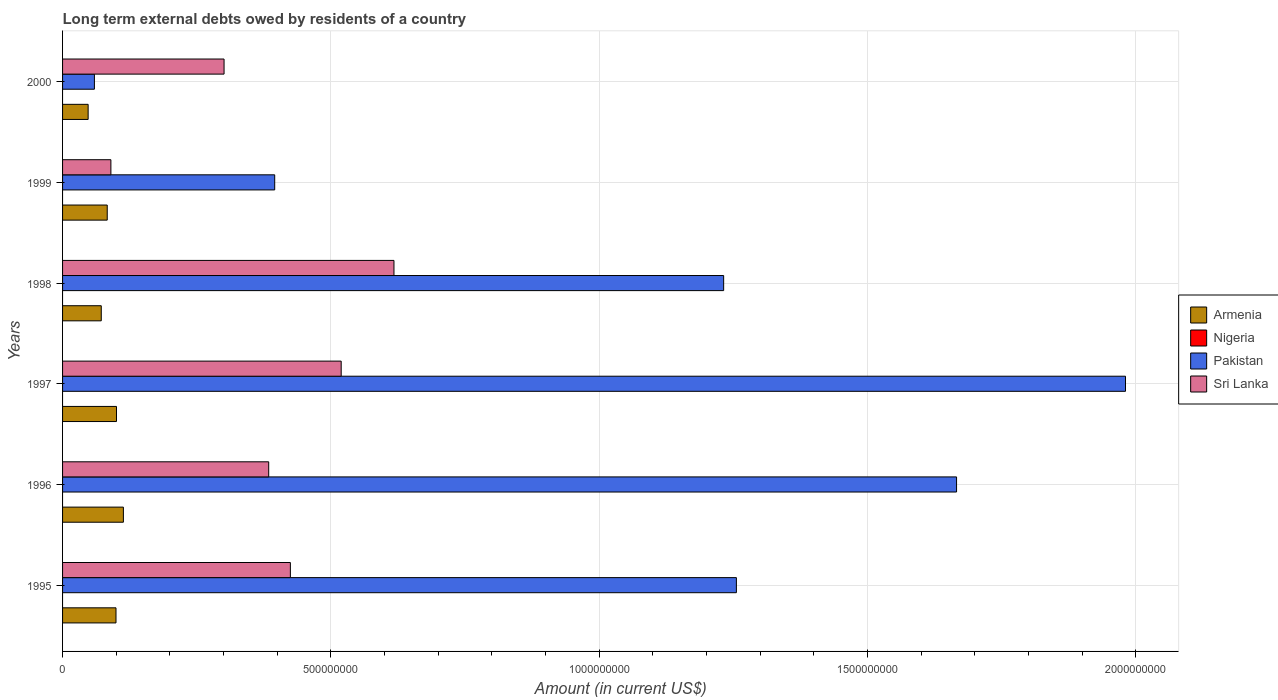How many different coloured bars are there?
Offer a very short reply. 3. How many bars are there on the 5th tick from the top?
Ensure brevity in your answer.  3. How many bars are there on the 6th tick from the bottom?
Provide a succinct answer. 3. In how many cases, is the number of bars for a given year not equal to the number of legend labels?
Offer a terse response. 6. Across all years, what is the maximum amount of long-term external debts owed by residents in Sri Lanka?
Offer a terse response. 6.17e+08. Across all years, what is the minimum amount of long-term external debts owed by residents in Sri Lanka?
Offer a very short reply. 9.00e+07. What is the total amount of long-term external debts owed by residents in Pakistan in the graph?
Provide a succinct answer. 6.59e+09. What is the difference between the amount of long-term external debts owed by residents in Armenia in 1997 and that in 1999?
Your answer should be very brief. 1.72e+07. What is the difference between the amount of long-term external debts owed by residents in Pakistan in 1995 and the amount of long-term external debts owed by residents in Sri Lanka in 1997?
Your answer should be compact. 7.36e+08. In the year 1995, what is the difference between the amount of long-term external debts owed by residents in Armenia and amount of long-term external debts owed by residents in Pakistan?
Your answer should be compact. -1.16e+09. What is the ratio of the amount of long-term external debts owed by residents in Armenia in 1995 to that in 1999?
Ensure brevity in your answer.  1.2. Is the difference between the amount of long-term external debts owed by residents in Armenia in 1997 and 1999 greater than the difference between the amount of long-term external debts owed by residents in Pakistan in 1997 and 1999?
Keep it short and to the point. No. What is the difference between the highest and the second highest amount of long-term external debts owed by residents in Sri Lanka?
Your response must be concise. 9.83e+07. What is the difference between the highest and the lowest amount of long-term external debts owed by residents in Sri Lanka?
Your answer should be very brief. 5.27e+08. In how many years, is the amount of long-term external debts owed by residents in Nigeria greater than the average amount of long-term external debts owed by residents in Nigeria taken over all years?
Keep it short and to the point. 0. Is it the case that in every year, the sum of the amount of long-term external debts owed by residents in Nigeria and amount of long-term external debts owed by residents in Armenia is greater than the sum of amount of long-term external debts owed by residents in Sri Lanka and amount of long-term external debts owed by residents in Pakistan?
Provide a short and direct response. No. Is it the case that in every year, the sum of the amount of long-term external debts owed by residents in Sri Lanka and amount of long-term external debts owed by residents in Pakistan is greater than the amount of long-term external debts owed by residents in Armenia?
Give a very brief answer. Yes. How many years are there in the graph?
Give a very brief answer. 6. Where does the legend appear in the graph?
Make the answer very short. Center right. What is the title of the graph?
Your answer should be compact. Long term external debts owed by residents of a country. Does "Aruba" appear as one of the legend labels in the graph?
Give a very brief answer. No. What is the label or title of the X-axis?
Offer a very short reply. Amount (in current US$). What is the Amount (in current US$) of Armenia in 1995?
Your answer should be very brief. 9.95e+07. What is the Amount (in current US$) of Pakistan in 1995?
Your answer should be compact. 1.26e+09. What is the Amount (in current US$) of Sri Lanka in 1995?
Your answer should be very brief. 4.24e+08. What is the Amount (in current US$) in Armenia in 1996?
Your response must be concise. 1.13e+08. What is the Amount (in current US$) in Nigeria in 1996?
Provide a short and direct response. 0. What is the Amount (in current US$) of Pakistan in 1996?
Your response must be concise. 1.67e+09. What is the Amount (in current US$) of Sri Lanka in 1996?
Provide a short and direct response. 3.84e+08. What is the Amount (in current US$) in Armenia in 1997?
Offer a very short reply. 1.00e+08. What is the Amount (in current US$) of Pakistan in 1997?
Your answer should be very brief. 1.98e+09. What is the Amount (in current US$) in Sri Lanka in 1997?
Your response must be concise. 5.19e+08. What is the Amount (in current US$) in Armenia in 1998?
Ensure brevity in your answer.  7.21e+07. What is the Amount (in current US$) in Pakistan in 1998?
Ensure brevity in your answer.  1.23e+09. What is the Amount (in current US$) in Sri Lanka in 1998?
Your response must be concise. 6.17e+08. What is the Amount (in current US$) in Armenia in 1999?
Give a very brief answer. 8.32e+07. What is the Amount (in current US$) of Nigeria in 1999?
Your answer should be compact. 0. What is the Amount (in current US$) in Pakistan in 1999?
Your response must be concise. 3.95e+08. What is the Amount (in current US$) of Sri Lanka in 1999?
Give a very brief answer. 9.00e+07. What is the Amount (in current US$) in Armenia in 2000?
Make the answer very short. 4.77e+07. What is the Amount (in current US$) of Nigeria in 2000?
Make the answer very short. 0. What is the Amount (in current US$) of Pakistan in 2000?
Your answer should be very brief. 5.93e+07. What is the Amount (in current US$) of Sri Lanka in 2000?
Your answer should be very brief. 3.01e+08. Across all years, what is the maximum Amount (in current US$) of Armenia?
Offer a very short reply. 1.13e+08. Across all years, what is the maximum Amount (in current US$) of Pakistan?
Give a very brief answer. 1.98e+09. Across all years, what is the maximum Amount (in current US$) of Sri Lanka?
Give a very brief answer. 6.17e+08. Across all years, what is the minimum Amount (in current US$) of Armenia?
Your answer should be compact. 4.77e+07. Across all years, what is the minimum Amount (in current US$) in Pakistan?
Make the answer very short. 5.93e+07. Across all years, what is the minimum Amount (in current US$) in Sri Lanka?
Keep it short and to the point. 9.00e+07. What is the total Amount (in current US$) in Armenia in the graph?
Provide a short and direct response. 5.16e+08. What is the total Amount (in current US$) of Pakistan in the graph?
Offer a terse response. 6.59e+09. What is the total Amount (in current US$) of Sri Lanka in the graph?
Your answer should be compact. 2.34e+09. What is the difference between the Amount (in current US$) of Armenia in 1995 and that in 1996?
Provide a short and direct response. -1.38e+07. What is the difference between the Amount (in current US$) in Pakistan in 1995 and that in 1996?
Provide a short and direct response. -4.10e+08. What is the difference between the Amount (in current US$) in Sri Lanka in 1995 and that in 1996?
Ensure brevity in your answer.  4.04e+07. What is the difference between the Amount (in current US$) in Armenia in 1995 and that in 1997?
Your answer should be very brief. -9.31e+05. What is the difference between the Amount (in current US$) of Pakistan in 1995 and that in 1997?
Provide a succinct answer. -7.25e+08. What is the difference between the Amount (in current US$) of Sri Lanka in 1995 and that in 1997?
Keep it short and to the point. -9.47e+07. What is the difference between the Amount (in current US$) of Armenia in 1995 and that in 1998?
Provide a short and direct response. 2.74e+07. What is the difference between the Amount (in current US$) in Pakistan in 1995 and that in 1998?
Provide a succinct answer. 2.37e+07. What is the difference between the Amount (in current US$) in Sri Lanka in 1995 and that in 1998?
Keep it short and to the point. -1.93e+08. What is the difference between the Amount (in current US$) in Armenia in 1995 and that in 1999?
Give a very brief answer. 1.63e+07. What is the difference between the Amount (in current US$) of Pakistan in 1995 and that in 1999?
Offer a very short reply. 8.60e+08. What is the difference between the Amount (in current US$) of Sri Lanka in 1995 and that in 1999?
Make the answer very short. 3.34e+08. What is the difference between the Amount (in current US$) of Armenia in 1995 and that in 2000?
Offer a very short reply. 5.19e+07. What is the difference between the Amount (in current US$) of Pakistan in 1995 and that in 2000?
Give a very brief answer. 1.20e+09. What is the difference between the Amount (in current US$) of Sri Lanka in 1995 and that in 2000?
Provide a succinct answer. 1.24e+08. What is the difference between the Amount (in current US$) in Armenia in 1996 and that in 1997?
Provide a short and direct response. 1.28e+07. What is the difference between the Amount (in current US$) in Pakistan in 1996 and that in 1997?
Give a very brief answer. -3.15e+08. What is the difference between the Amount (in current US$) in Sri Lanka in 1996 and that in 1997?
Provide a succinct answer. -1.35e+08. What is the difference between the Amount (in current US$) of Armenia in 1996 and that in 1998?
Your response must be concise. 4.12e+07. What is the difference between the Amount (in current US$) in Pakistan in 1996 and that in 1998?
Give a very brief answer. 4.34e+08. What is the difference between the Amount (in current US$) in Sri Lanka in 1996 and that in 1998?
Offer a terse response. -2.33e+08. What is the difference between the Amount (in current US$) in Armenia in 1996 and that in 1999?
Give a very brief answer. 3.01e+07. What is the difference between the Amount (in current US$) in Pakistan in 1996 and that in 1999?
Your answer should be very brief. 1.27e+09. What is the difference between the Amount (in current US$) in Sri Lanka in 1996 and that in 1999?
Your answer should be compact. 2.94e+08. What is the difference between the Amount (in current US$) in Armenia in 1996 and that in 2000?
Make the answer very short. 6.57e+07. What is the difference between the Amount (in current US$) of Pakistan in 1996 and that in 2000?
Provide a short and direct response. 1.61e+09. What is the difference between the Amount (in current US$) in Sri Lanka in 1996 and that in 2000?
Provide a short and direct response. 8.32e+07. What is the difference between the Amount (in current US$) in Armenia in 1997 and that in 1998?
Provide a succinct answer. 2.84e+07. What is the difference between the Amount (in current US$) of Pakistan in 1997 and that in 1998?
Your response must be concise. 7.49e+08. What is the difference between the Amount (in current US$) in Sri Lanka in 1997 and that in 1998?
Provide a short and direct response. -9.83e+07. What is the difference between the Amount (in current US$) in Armenia in 1997 and that in 1999?
Your response must be concise. 1.72e+07. What is the difference between the Amount (in current US$) in Pakistan in 1997 and that in 1999?
Give a very brief answer. 1.59e+09. What is the difference between the Amount (in current US$) in Sri Lanka in 1997 and that in 1999?
Your answer should be very brief. 4.29e+08. What is the difference between the Amount (in current US$) in Armenia in 1997 and that in 2000?
Keep it short and to the point. 5.28e+07. What is the difference between the Amount (in current US$) of Pakistan in 1997 and that in 2000?
Provide a short and direct response. 1.92e+09. What is the difference between the Amount (in current US$) of Sri Lanka in 1997 and that in 2000?
Ensure brevity in your answer.  2.18e+08. What is the difference between the Amount (in current US$) in Armenia in 1998 and that in 1999?
Make the answer very short. -1.11e+07. What is the difference between the Amount (in current US$) of Pakistan in 1998 and that in 1999?
Your answer should be compact. 8.37e+08. What is the difference between the Amount (in current US$) in Sri Lanka in 1998 and that in 1999?
Provide a succinct answer. 5.27e+08. What is the difference between the Amount (in current US$) of Armenia in 1998 and that in 2000?
Ensure brevity in your answer.  2.45e+07. What is the difference between the Amount (in current US$) of Pakistan in 1998 and that in 2000?
Your answer should be very brief. 1.17e+09. What is the difference between the Amount (in current US$) in Sri Lanka in 1998 and that in 2000?
Offer a very short reply. 3.17e+08. What is the difference between the Amount (in current US$) of Armenia in 1999 and that in 2000?
Your answer should be compact. 3.56e+07. What is the difference between the Amount (in current US$) in Pakistan in 1999 and that in 2000?
Provide a short and direct response. 3.36e+08. What is the difference between the Amount (in current US$) in Sri Lanka in 1999 and that in 2000?
Your response must be concise. -2.11e+08. What is the difference between the Amount (in current US$) in Armenia in 1995 and the Amount (in current US$) in Pakistan in 1996?
Give a very brief answer. -1.57e+09. What is the difference between the Amount (in current US$) in Armenia in 1995 and the Amount (in current US$) in Sri Lanka in 1996?
Provide a succinct answer. -2.85e+08. What is the difference between the Amount (in current US$) of Pakistan in 1995 and the Amount (in current US$) of Sri Lanka in 1996?
Provide a short and direct response. 8.71e+08. What is the difference between the Amount (in current US$) in Armenia in 1995 and the Amount (in current US$) in Pakistan in 1997?
Keep it short and to the point. -1.88e+09. What is the difference between the Amount (in current US$) in Armenia in 1995 and the Amount (in current US$) in Sri Lanka in 1997?
Offer a very short reply. -4.20e+08. What is the difference between the Amount (in current US$) in Pakistan in 1995 and the Amount (in current US$) in Sri Lanka in 1997?
Your answer should be very brief. 7.36e+08. What is the difference between the Amount (in current US$) in Armenia in 1995 and the Amount (in current US$) in Pakistan in 1998?
Make the answer very short. -1.13e+09. What is the difference between the Amount (in current US$) of Armenia in 1995 and the Amount (in current US$) of Sri Lanka in 1998?
Make the answer very short. -5.18e+08. What is the difference between the Amount (in current US$) of Pakistan in 1995 and the Amount (in current US$) of Sri Lanka in 1998?
Offer a very short reply. 6.38e+08. What is the difference between the Amount (in current US$) of Armenia in 1995 and the Amount (in current US$) of Pakistan in 1999?
Your response must be concise. -2.96e+08. What is the difference between the Amount (in current US$) of Armenia in 1995 and the Amount (in current US$) of Sri Lanka in 1999?
Keep it short and to the point. 9.52e+06. What is the difference between the Amount (in current US$) in Pakistan in 1995 and the Amount (in current US$) in Sri Lanka in 1999?
Provide a short and direct response. 1.17e+09. What is the difference between the Amount (in current US$) in Armenia in 1995 and the Amount (in current US$) in Pakistan in 2000?
Your answer should be very brief. 4.02e+07. What is the difference between the Amount (in current US$) of Armenia in 1995 and the Amount (in current US$) of Sri Lanka in 2000?
Give a very brief answer. -2.01e+08. What is the difference between the Amount (in current US$) of Pakistan in 1995 and the Amount (in current US$) of Sri Lanka in 2000?
Offer a very short reply. 9.55e+08. What is the difference between the Amount (in current US$) of Armenia in 1996 and the Amount (in current US$) of Pakistan in 1997?
Keep it short and to the point. -1.87e+09. What is the difference between the Amount (in current US$) in Armenia in 1996 and the Amount (in current US$) in Sri Lanka in 1997?
Provide a short and direct response. -4.06e+08. What is the difference between the Amount (in current US$) of Pakistan in 1996 and the Amount (in current US$) of Sri Lanka in 1997?
Provide a short and direct response. 1.15e+09. What is the difference between the Amount (in current US$) of Armenia in 1996 and the Amount (in current US$) of Pakistan in 1998?
Give a very brief answer. -1.12e+09. What is the difference between the Amount (in current US$) of Armenia in 1996 and the Amount (in current US$) of Sri Lanka in 1998?
Make the answer very short. -5.04e+08. What is the difference between the Amount (in current US$) in Pakistan in 1996 and the Amount (in current US$) in Sri Lanka in 1998?
Provide a succinct answer. 1.05e+09. What is the difference between the Amount (in current US$) of Armenia in 1996 and the Amount (in current US$) of Pakistan in 1999?
Make the answer very short. -2.82e+08. What is the difference between the Amount (in current US$) of Armenia in 1996 and the Amount (in current US$) of Sri Lanka in 1999?
Make the answer very short. 2.33e+07. What is the difference between the Amount (in current US$) of Pakistan in 1996 and the Amount (in current US$) of Sri Lanka in 1999?
Give a very brief answer. 1.58e+09. What is the difference between the Amount (in current US$) in Armenia in 1996 and the Amount (in current US$) in Pakistan in 2000?
Offer a very short reply. 5.40e+07. What is the difference between the Amount (in current US$) of Armenia in 1996 and the Amount (in current US$) of Sri Lanka in 2000?
Provide a short and direct response. -1.88e+08. What is the difference between the Amount (in current US$) of Pakistan in 1996 and the Amount (in current US$) of Sri Lanka in 2000?
Ensure brevity in your answer.  1.36e+09. What is the difference between the Amount (in current US$) in Armenia in 1997 and the Amount (in current US$) in Pakistan in 1998?
Your answer should be very brief. -1.13e+09. What is the difference between the Amount (in current US$) in Armenia in 1997 and the Amount (in current US$) in Sri Lanka in 1998?
Your answer should be very brief. -5.17e+08. What is the difference between the Amount (in current US$) in Pakistan in 1997 and the Amount (in current US$) in Sri Lanka in 1998?
Your answer should be very brief. 1.36e+09. What is the difference between the Amount (in current US$) in Armenia in 1997 and the Amount (in current US$) in Pakistan in 1999?
Ensure brevity in your answer.  -2.95e+08. What is the difference between the Amount (in current US$) of Armenia in 1997 and the Amount (in current US$) of Sri Lanka in 1999?
Make the answer very short. 1.04e+07. What is the difference between the Amount (in current US$) of Pakistan in 1997 and the Amount (in current US$) of Sri Lanka in 1999?
Provide a succinct answer. 1.89e+09. What is the difference between the Amount (in current US$) of Armenia in 1997 and the Amount (in current US$) of Pakistan in 2000?
Provide a succinct answer. 4.12e+07. What is the difference between the Amount (in current US$) in Armenia in 1997 and the Amount (in current US$) in Sri Lanka in 2000?
Provide a short and direct response. -2.00e+08. What is the difference between the Amount (in current US$) in Pakistan in 1997 and the Amount (in current US$) in Sri Lanka in 2000?
Ensure brevity in your answer.  1.68e+09. What is the difference between the Amount (in current US$) of Armenia in 1998 and the Amount (in current US$) of Pakistan in 1999?
Provide a succinct answer. -3.23e+08. What is the difference between the Amount (in current US$) of Armenia in 1998 and the Amount (in current US$) of Sri Lanka in 1999?
Make the answer very short. -1.79e+07. What is the difference between the Amount (in current US$) of Pakistan in 1998 and the Amount (in current US$) of Sri Lanka in 1999?
Ensure brevity in your answer.  1.14e+09. What is the difference between the Amount (in current US$) in Armenia in 1998 and the Amount (in current US$) in Pakistan in 2000?
Your answer should be compact. 1.28e+07. What is the difference between the Amount (in current US$) of Armenia in 1998 and the Amount (in current US$) of Sri Lanka in 2000?
Keep it short and to the point. -2.29e+08. What is the difference between the Amount (in current US$) in Pakistan in 1998 and the Amount (in current US$) in Sri Lanka in 2000?
Offer a terse response. 9.31e+08. What is the difference between the Amount (in current US$) of Armenia in 1999 and the Amount (in current US$) of Pakistan in 2000?
Your response must be concise. 2.39e+07. What is the difference between the Amount (in current US$) of Armenia in 1999 and the Amount (in current US$) of Sri Lanka in 2000?
Offer a terse response. -2.18e+08. What is the difference between the Amount (in current US$) of Pakistan in 1999 and the Amount (in current US$) of Sri Lanka in 2000?
Your answer should be very brief. 9.44e+07. What is the average Amount (in current US$) in Armenia per year?
Your response must be concise. 8.61e+07. What is the average Amount (in current US$) in Pakistan per year?
Ensure brevity in your answer.  1.10e+09. What is the average Amount (in current US$) in Sri Lanka per year?
Keep it short and to the point. 3.89e+08. In the year 1995, what is the difference between the Amount (in current US$) of Armenia and Amount (in current US$) of Pakistan?
Make the answer very short. -1.16e+09. In the year 1995, what is the difference between the Amount (in current US$) of Armenia and Amount (in current US$) of Sri Lanka?
Offer a very short reply. -3.25e+08. In the year 1995, what is the difference between the Amount (in current US$) of Pakistan and Amount (in current US$) of Sri Lanka?
Keep it short and to the point. 8.31e+08. In the year 1996, what is the difference between the Amount (in current US$) of Armenia and Amount (in current US$) of Pakistan?
Provide a short and direct response. -1.55e+09. In the year 1996, what is the difference between the Amount (in current US$) of Armenia and Amount (in current US$) of Sri Lanka?
Keep it short and to the point. -2.71e+08. In the year 1996, what is the difference between the Amount (in current US$) in Pakistan and Amount (in current US$) in Sri Lanka?
Ensure brevity in your answer.  1.28e+09. In the year 1997, what is the difference between the Amount (in current US$) in Armenia and Amount (in current US$) in Pakistan?
Ensure brevity in your answer.  -1.88e+09. In the year 1997, what is the difference between the Amount (in current US$) in Armenia and Amount (in current US$) in Sri Lanka?
Provide a succinct answer. -4.19e+08. In the year 1997, what is the difference between the Amount (in current US$) in Pakistan and Amount (in current US$) in Sri Lanka?
Give a very brief answer. 1.46e+09. In the year 1998, what is the difference between the Amount (in current US$) in Armenia and Amount (in current US$) in Pakistan?
Offer a very short reply. -1.16e+09. In the year 1998, what is the difference between the Amount (in current US$) in Armenia and Amount (in current US$) in Sri Lanka?
Your answer should be compact. -5.45e+08. In the year 1998, what is the difference between the Amount (in current US$) in Pakistan and Amount (in current US$) in Sri Lanka?
Provide a short and direct response. 6.14e+08. In the year 1999, what is the difference between the Amount (in current US$) of Armenia and Amount (in current US$) of Pakistan?
Provide a succinct answer. -3.12e+08. In the year 1999, what is the difference between the Amount (in current US$) of Armenia and Amount (in current US$) of Sri Lanka?
Offer a very short reply. -6.80e+06. In the year 1999, what is the difference between the Amount (in current US$) in Pakistan and Amount (in current US$) in Sri Lanka?
Your answer should be compact. 3.05e+08. In the year 2000, what is the difference between the Amount (in current US$) of Armenia and Amount (in current US$) of Pakistan?
Your answer should be very brief. -1.17e+07. In the year 2000, what is the difference between the Amount (in current US$) of Armenia and Amount (in current US$) of Sri Lanka?
Your answer should be compact. -2.53e+08. In the year 2000, what is the difference between the Amount (in current US$) of Pakistan and Amount (in current US$) of Sri Lanka?
Your answer should be compact. -2.42e+08. What is the ratio of the Amount (in current US$) of Armenia in 1995 to that in 1996?
Your answer should be very brief. 0.88. What is the ratio of the Amount (in current US$) of Pakistan in 1995 to that in 1996?
Keep it short and to the point. 0.75. What is the ratio of the Amount (in current US$) of Sri Lanka in 1995 to that in 1996?
Ensure brevity in your answer.  1.11. What is the ratio of the Amount (in current US$) in Pakistan in 1995 to that in 1997?
Provide a short and direct response. 0.63. What is the ratio of the Amount (in current US$) in Sri Lanka in 1995 to that in 1997?
Provide a succinct answer. 0.82. What is the ratio of the Amount (in current US$) of Armenia in 1995 to that in 1998?
Your answer should be compact. 1.38. What is the ratio of the Amount (in current US$) in Pakistan in 1995 to that in 1998?
Make the answer very short. 1.02. What is the ratio of the Amount (in current US$) of Sri Lanka in 1995 to that in 1998?
Your answer should be compact. 0.69. What is the ratio of the Amount (in current US$) of Armenia in 1995 to that in 1999?
Your answer should be very brief. 1.2. What is the ratio of the Amount (in current US$) in Pakistan in 1995 to that in 1999?
Your answer should be compact. 3.18. What is the ratio of the Amount (in current US$) of Sri Lanka in 1995 to that in 1999?
Keep it short and to the point. 4.71. What is the ratio of the Amount (in current US$) in Armenia in 1995 to that in 2000?
Make the answer very short. 2.09. What is the ratio of the Amount (in current US$) of Pakistan in 1995 to that in 2000?
Your answer should be compact. 21.17. What is the ratio of the Amount (in current US$) of Sri Lanka in 1995 to that in 2000?
Your response must be concise. 1.41. What is the ratio of the Amount (in current US$) of Armenia in 1996 to that in 1997?
Offer a very short reply. 1.13. What is the ratio of the Amount (in current US$) of Pakistan in 1996 to that in 1997?
Keep it short and to the point. 0.84. What is the ratio of the Amount (in current US$) in Sri Lanka in 1996 to that in 1997?
Ensure brevity in your answer.  0.74. What is the ratio of the Amount (in current US$) in Armenia in 1996 to that in 1998?
Your answer should be compact. 1.57. What is the ratio of the Amount (in current US$) of Pakistan in 1996 to that in 1998?
Provide a short and direct response. 1.35. What is the ratio of the Amount (in current US$) of Sri Lanka in 1996 to that in 1998?
Provide a succinct answer. 0.62. What is the ratio of the Amount (in current US$) of Armenia in 1996 to that in 1999?
Keep it short and to the point. 1.36. What is the ratio of the Amount (in current US$) of Pakistan in 1996 to that in 1999?
Your response must be concise. 4.21. What is the ratio of the Amount (in current US$) in Sri Lanka in 1996 to that in 1999?
Your answer should be compact. 4.27. What is the ratio of the Amount (in current US$) of Armenia in 1996 to that in 2000?
Your answer should be very brief. 2.38. What is the ratio of the Amount (in current US$) in Pakistan in 1996 to that in 2000?
Your answer should be compact. 28.08. What is the ratio of the Amount (in current US$) in Sri Lanka in 1996 to that in 2000?
Give a very brief answer. 1.28. What is the ratio of the Amount (in current US$) in Armenia in 1997 to that in 1998?
Your answer should be compact. 1.39. What is the ratio of the Amount (in current US$) in Pakistan in 1997 to that in 1998?
Keep it short and to the point. 1.61. What is the ratio of the Amount (in current US$) in Sri Lanka in 1997 to that in 1998?
Provide a succinct answer. 0.84. What is the ratio of the Amount (in current US$) of Armenia in 1997 to that in 1999?
Provide a short and direct response. 1.21. What is the ratio of the Amount (in current US$) of Pakistan in 1997 to that in 1999?
Make the answer very short. 5.01. What is the ratio of the Amount (in current US$) of Sri Lanka in 1997 to that in 1999?
Offer a very short reply. 5.77. What is the ratio of the Amount (in current US$) in Armenia in 1997 to that in 2000?
Keep it short and to the point. 2.11. What is the ratio of the Amount (in current US$) in Pakistan in 1997 to that in 2000?
Offer a very short reply. 33.39. What is the ratio of the Amount (in current US$) of Sri Lanka in 1997 to that in 2000?
Make the answer very short. 1.73. What is the ratio of the Amount (in current US$) in Armenia in 1998 to that in 1999?
Ensure brevity in your answer.  0.87. What is the ratio of the Amount (in current US$) in Pakistan in 1998 to that in 1999?
Offer a terse response. 3.12. What is the ratio of the Amount (in current US$) in Sri Lanka in 1998 to that in 1999?
Your answer should be compact. 6.86. What is the ratio of the Amount (in current US$) of Armenia in 1998 to that in 2000?
Provide a short and direct response. 1.51. What is the ratio of the Amount (in current US$) in Pakistan in 1998 to that in 2000?
Your response must be concise. 20.77. What is the ratio of the Amount (in current US$) in Sri Lanka in 1998 to that in 2000?
Your answer should be compact. 2.05. What is the ratio of the Amount (in current US$) of Armenia in 1999 to that in 2000?
Provide a succinct answer. 1.75. What is the ratio of the Amount (in current US$) in Pakistan in 1999 to that in 2000?
Make the answer very short. 6.66. What is the ratio of the Amount (in current US$) of Sri Lanka in 1999 to that in 2000?
Your answer should be very brief. 0.3. What is the difference between the highest and the second highest Amount (in current US$) in Armenia?
Provide a short and direct response. 1.28e+07. What is the difference between the highest and the second highest Amount (in current US$) of Pakistan?
Give a very brief answer. 3.15e+08. What is the difference between the highest and the second highest Amount (in current US$) of Sri Lanka?
Offer a very short reply. 9.83e+07. What is the difference between the highest and the lowest Amount (in current US$) of Armenia?
Make the answer very short. 6.57e+07. What is the difference between the highest and the lowest Amount (in current US$) in Pakistan?
Offer a terse response. 1.92e+09. What is the difference between the highest and the lowest Amount (in current US$) in Sri Lanka?
Offer a terse response. 5.27e+08. 